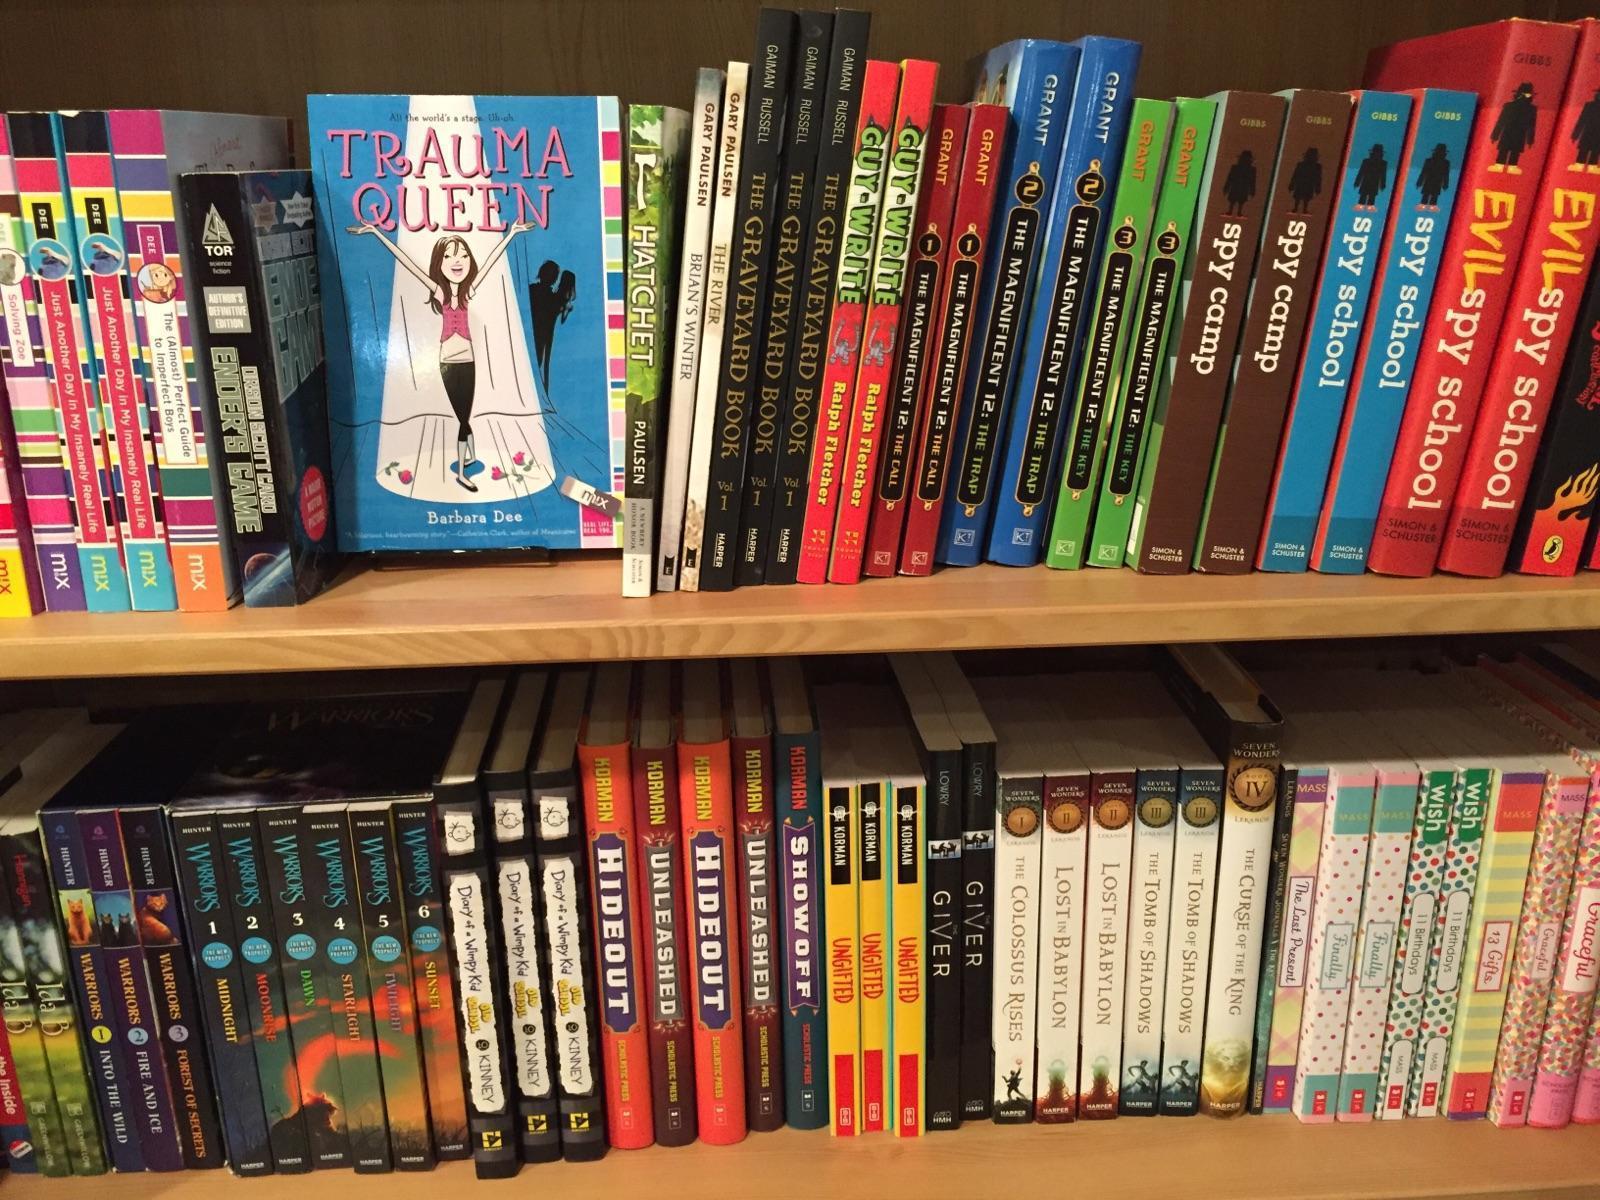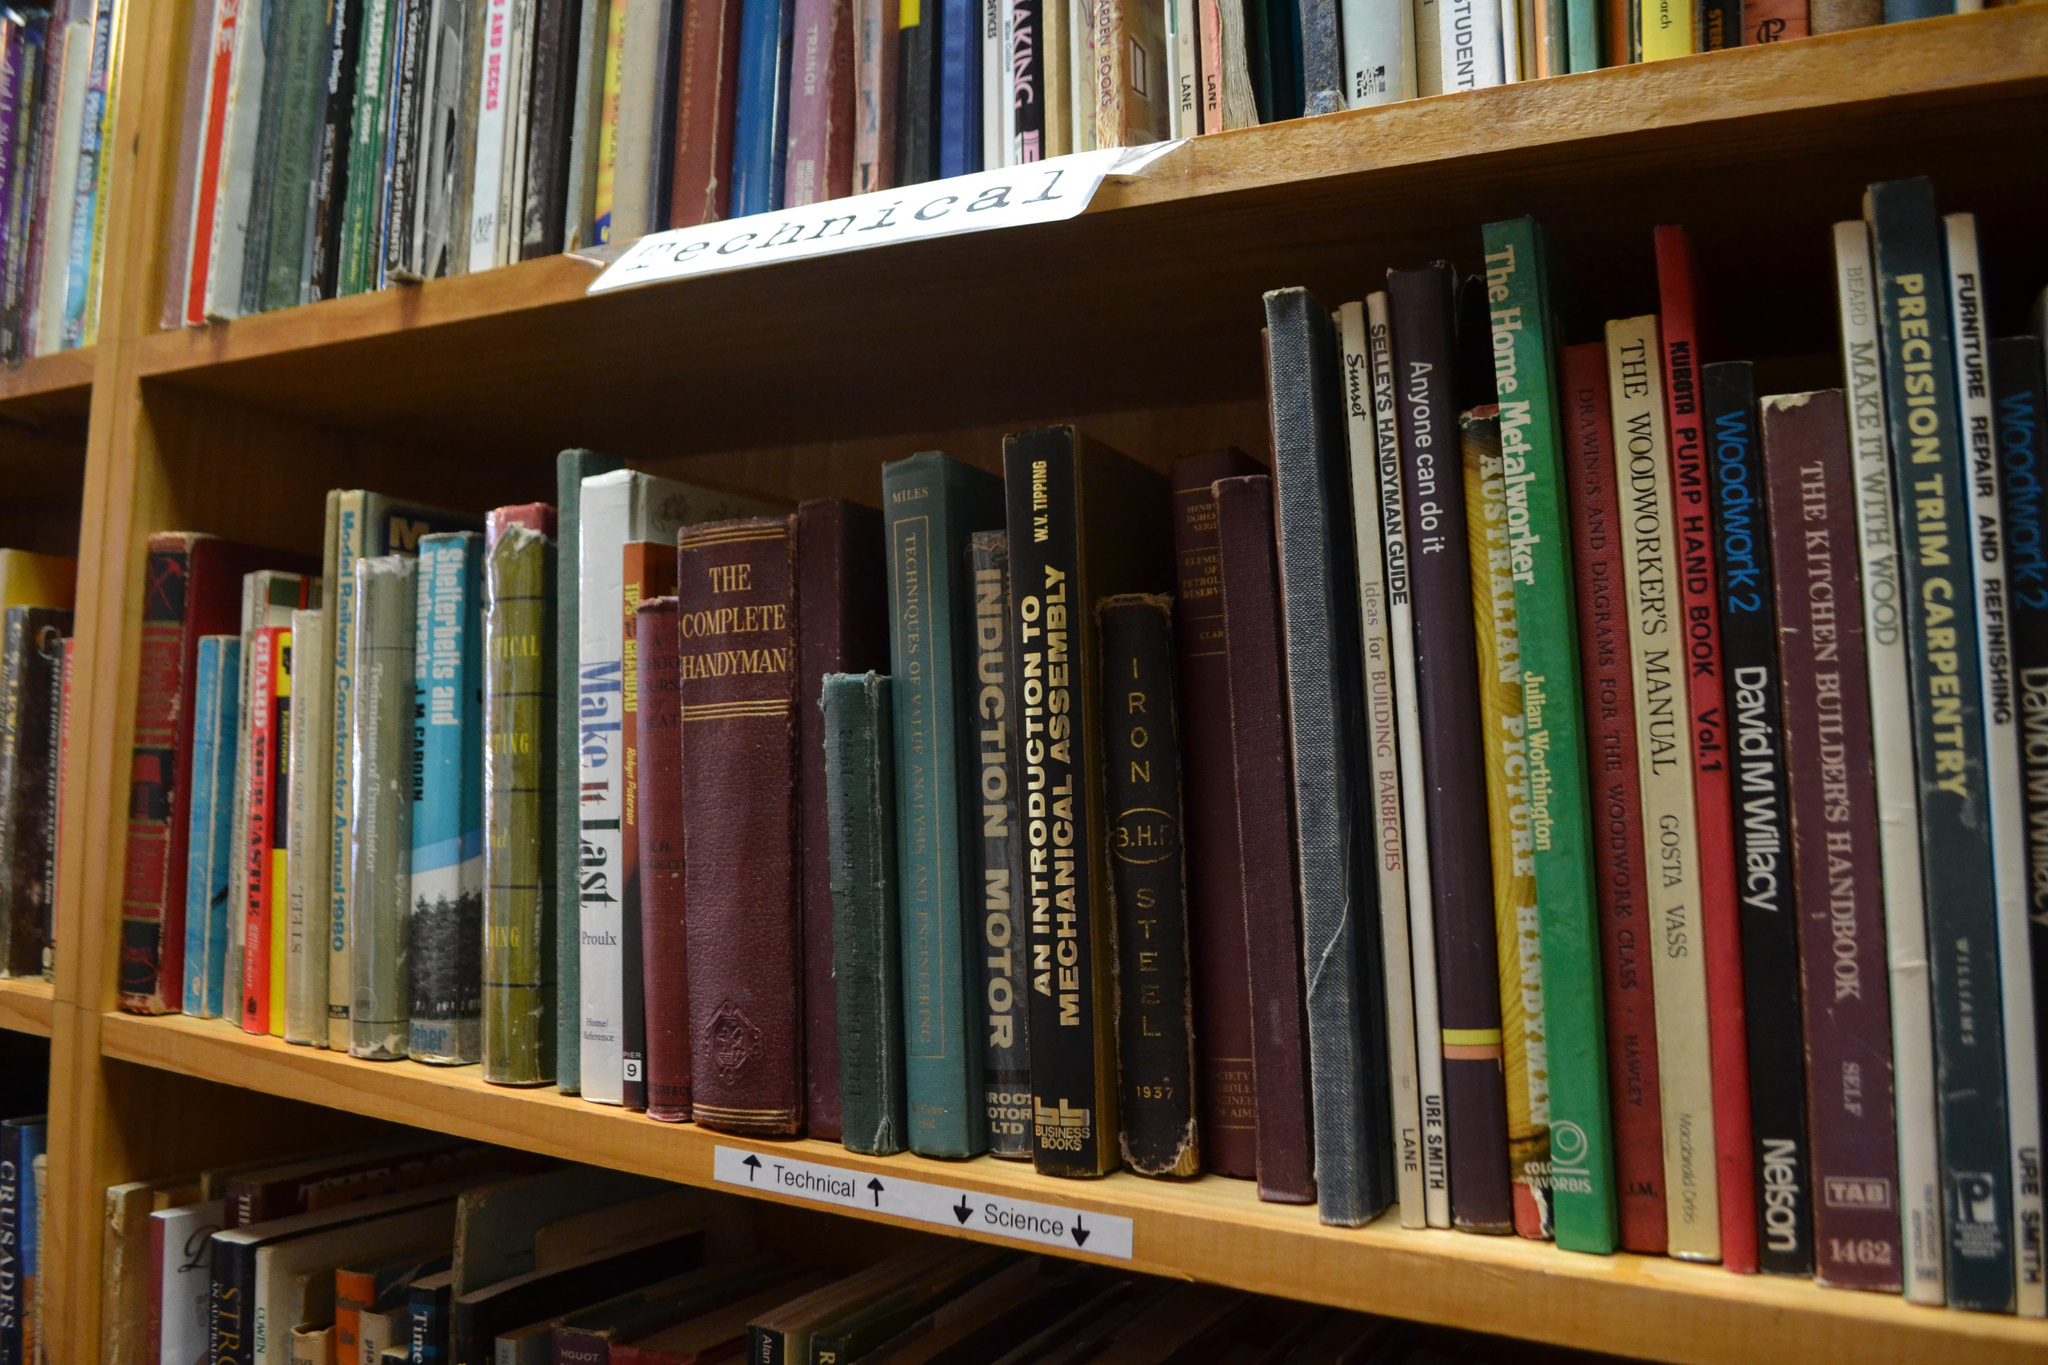The first image is the image on the left, the second image is the image on the right. For the images shown, is this caption "The right image shows at least one book withe its pages splayed open." true? Answer yes or no. No. The first image is the image on the left, the second image is the image on the right. Evaluate the accuracy of this statement regarding the images: "there are open books laying next to a stack of 6 books next to it". Is it true? Answer yes or no. No. 